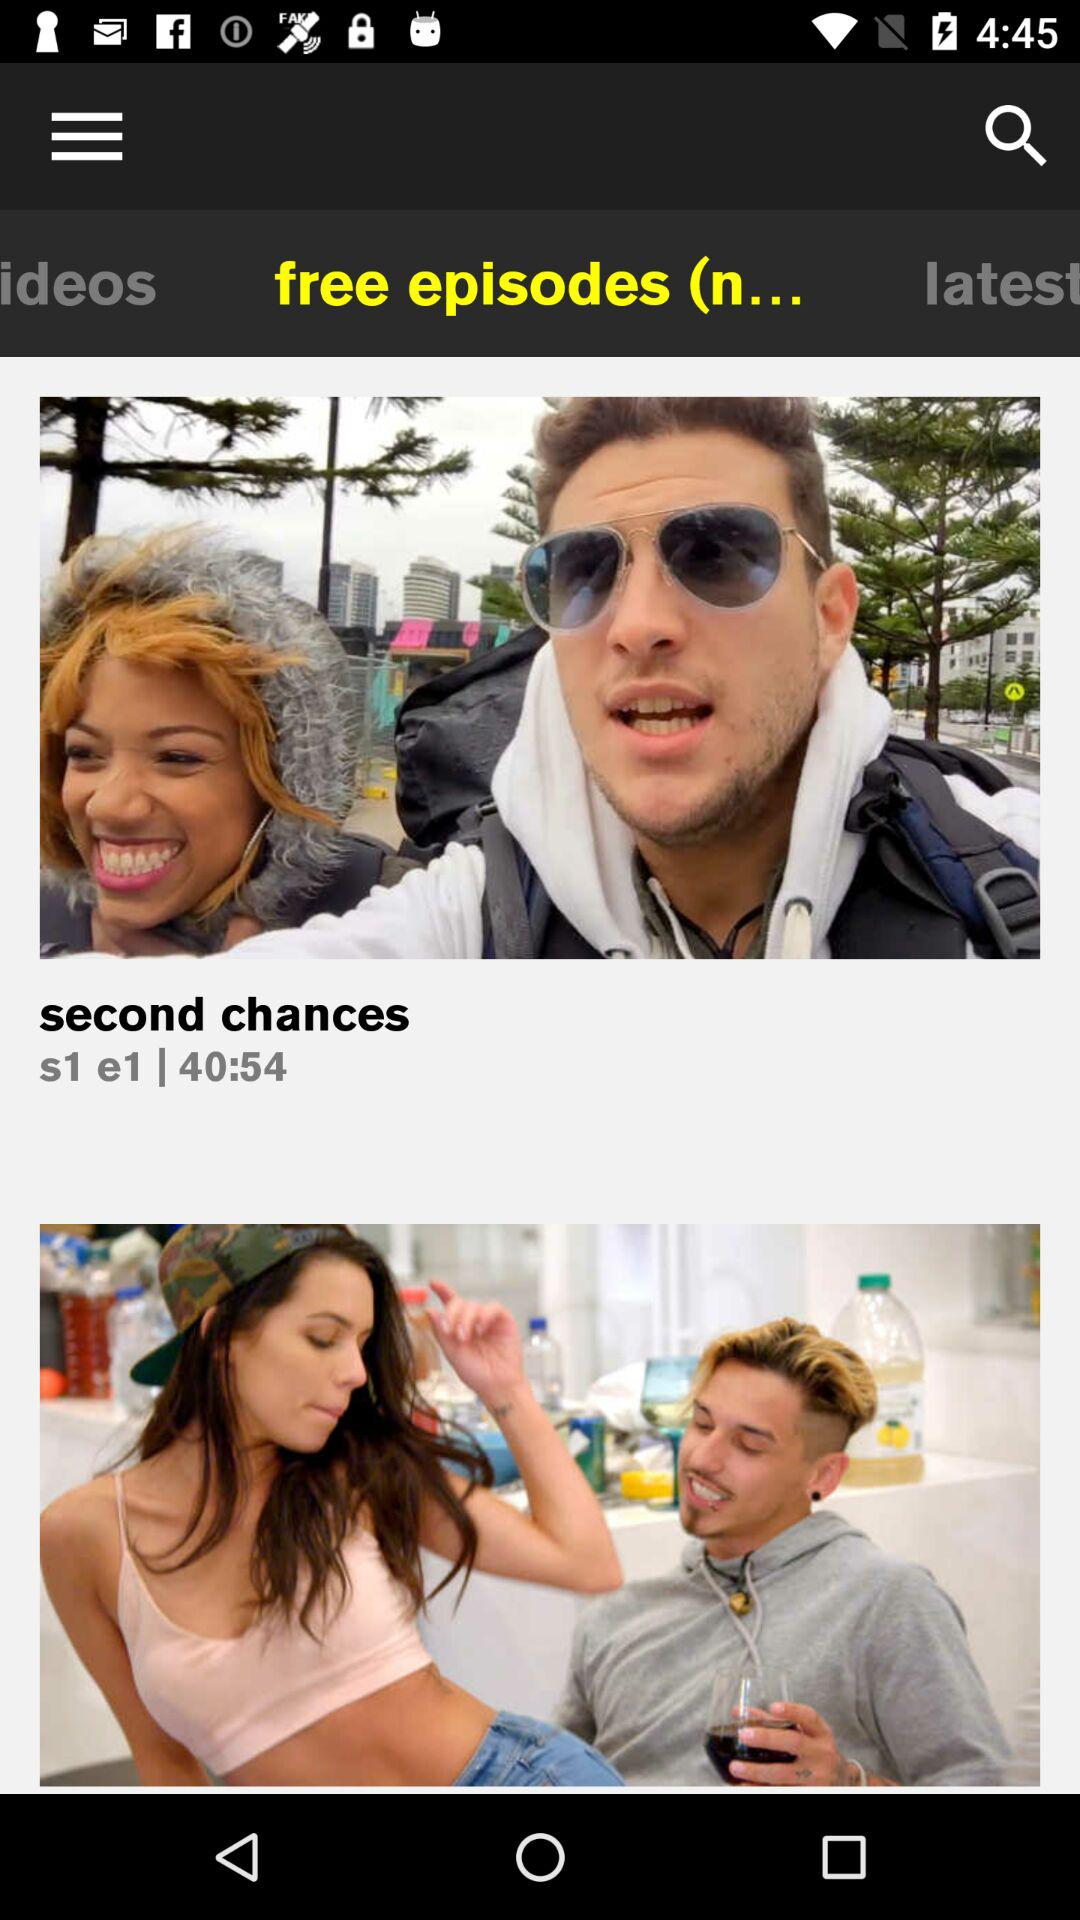What is the season number? The season number is 1. 